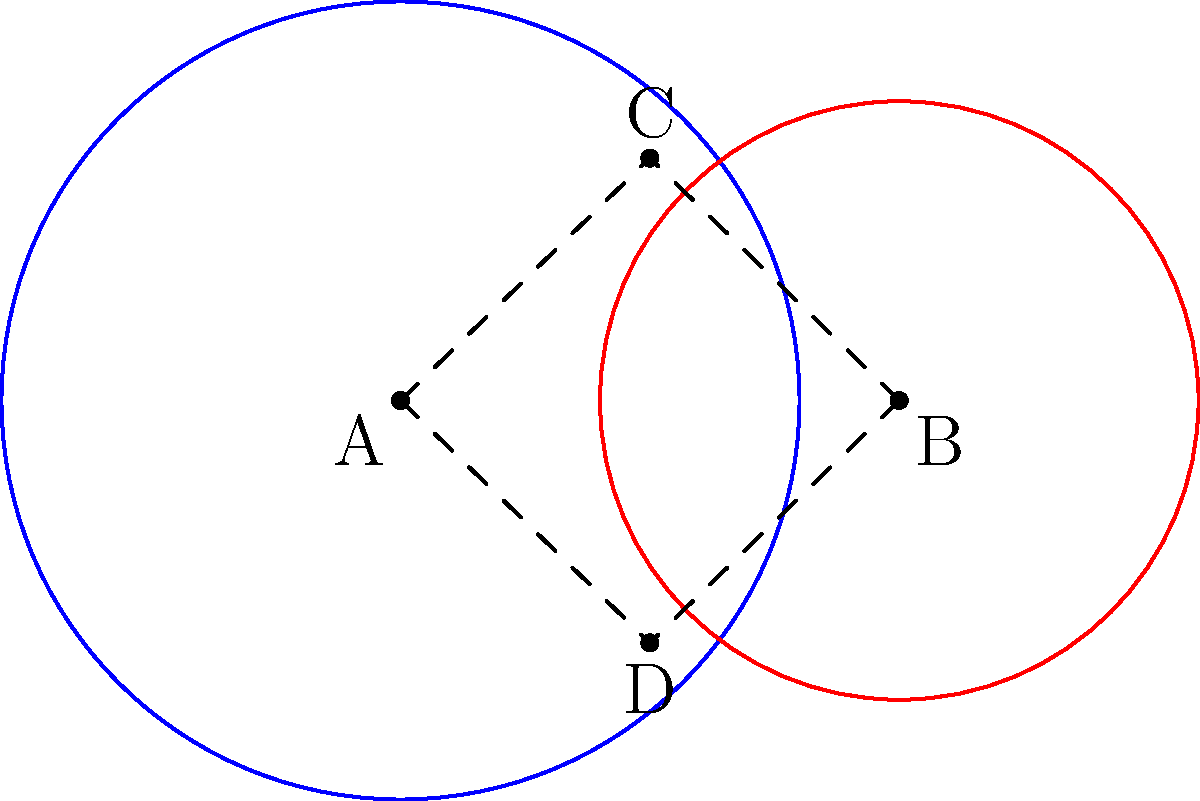Two churches, represented by circles A and B, have overlapping communities. Circle A has a radius of 4 miles, and circle B has a radius of 3 miles. The centers of the circles are 5 miles apart. What is the area of the region where the two church communities overlap? To find the area of overlap between two circles, we can use the following steps:

1. Find the distance between the centers (d):
   $d = 5$ miles (given)

2. Calculate the radii (r1 and r2):
   $r1 = 4$ miles, $r2 = 3$ miles (given)

3. Check if the circles intersect:
   $r1 + r2 > d > |r1 - r2|$
   $7 > 5 > 1$, so they intersect

4. Calculate the central angles $\theta_1$ and $\theta_2$:
   $$\theta_1 = 2 \arccos\left(\frac{r1^2 - r2^2 + d^2}{2r1d}\right)$$
   $$\theta_2 = 2 \arccos\left(\frac{r2^2 - r1^2 + d^2}{2r2d}\right)$$

   $\theta_1 = 2 \arccos\left(\frac{4^2 - 3^2 + 5^2}{2 \cdot 4 \cdot 5}\right) = 2.214$ radians
   $\theta_2 = 2 \arccos\left(\frac{3^2 - 4^2 + 5^2}{2 \cdot 3 \cdot 5}\right) = 3.142$ radians

5. Calculate the area of overlap:
   $$A = \frac{1}{2}r1^2(\theta_1 - \sin\theta_1) + \frac{1}{2}r2^2(\theta_2 - \sin\theta_2)$$
   
   $A = \frac{1}{2}(4^2)(2.214 - \sin(2.214)) + \frac{1}{2}(3^2)(3.142 - \sin(3.142))$
   $A = 8.372 + 6.205 = 14.577$ square miles

Therefore, the area of overlap is approximately 14.58 square miles.
Answer: 14.58 square miles 